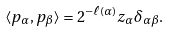Convert formula to latex. <formula><loc_0><loc_0><loc_500><loc_500>\langle p _ { \alpha } , p _ { \beta } \rangle = 2 ^ { - \ell ( \alpha ) } z _ { \alpha } \delta _ { \alpha \beta } .</formula> 